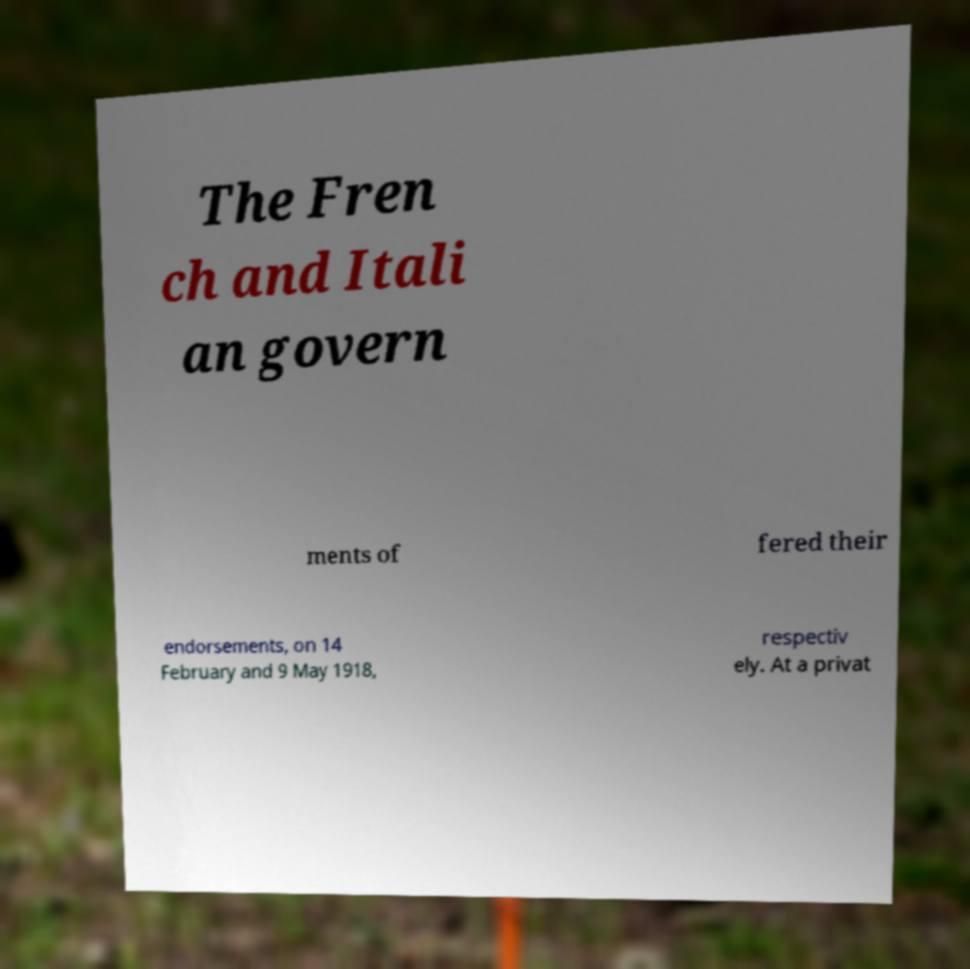I need the written content from this picture converted into text. Can you do that? The Fren ch and Itali an govern ments of fered their endorsements, on 14 February and 9 May 1918, respectiv ely. At a privat 